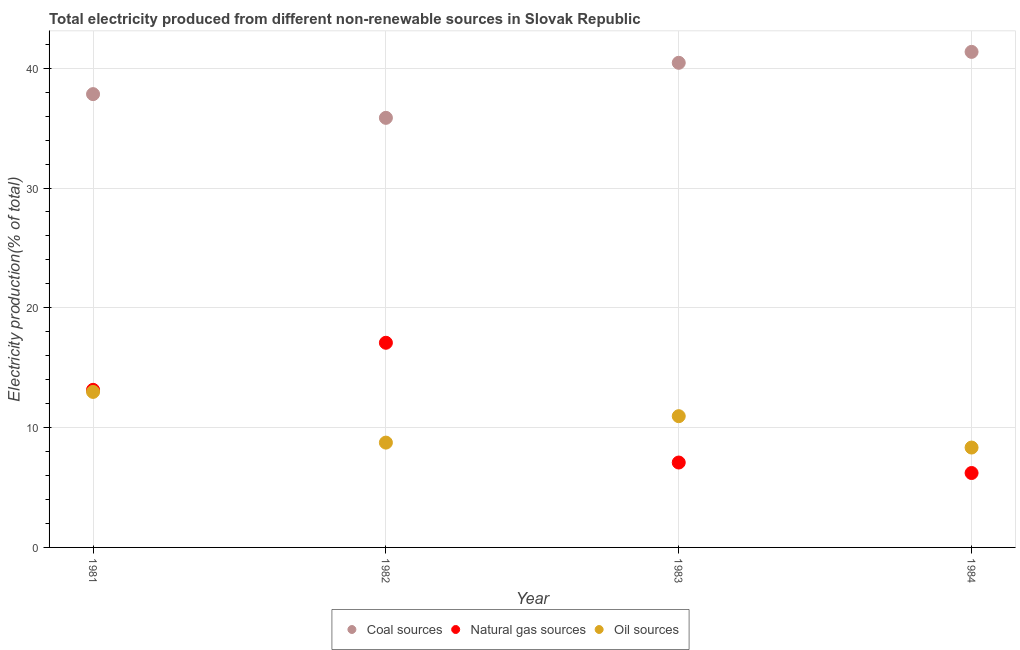What is the percentage of electricity produced by oil sources in 1982?
Make the answer very short. 8.75. Across all years, what is the maximum percentage of electricity produced by coal?
Offer a terse response. 41.36. Across all years, what is the minimum percentage of electricity produced by coal?
Provide a succinct answer. 35.86. What is the total percentage of electricity produced by natural gas in the graph?
Your answer should be compact. 43.54. What is the difference between the percentage of electricity produced by oil sources in 1982 and that in 1984?
Provide a short and direct response. 0.41. What is the difference between the percentage of electricity produced by natural gas in 1982 and the percentage of electricity produced by oil sources in 1984?
Provide a succinct answer. 8.75. What is the average percentage of electricity produced by coal per year?
Offer a terse response. 38.88. In the year 1984, what is the difference between the percentage of electricity produced by natural gas and percentage of electricity produced by coal?
Keep it short and to the point. -35.15. In how many years, is the percentage of electricity produced by oil sources greater than 36 %?
Provide a succinct answer. 0. What is the ratio of the percentage of electricity produced by oil sources in 1983 to that in 1984?
Your response must be concise. 1.31. Is the percentage of electricity produced by oil sources in 1982 less than that in 1984?
Offer a terse response. No. Is the difference between the percentage of electricity produced by oil sources in 1981 and 1982 greater than the difference between the percentage of electricity produced by coal in 1981 and 1982?
Your answer should be compact. Yes. What is the difference between the highest and the second highest percentage of electricity produced by oil sources?
Your response must be concise. 2.03. What is the difference between the highest and the lowest percentage of electricity produced by oil sources?
Provide a succinct answer. 4.64. In how many years, is the percentage of electricity produced by coal greater than the average percentage of electricity produced by coal taken over all years?
Provide a short and direct response. 2. Is the sum of the percentage of electricity produced by coal in 1981 and 1982 greater than the maximum percentage of electricity produced by natural gas across all years?
Provide a short and direct response. Yes. Is it the case that in every year, the sum of the percentage of electricity produced by coal and percentage of electricity produced by natural gas is greater than the percentage of electricity produced by oil sources?
Your answer should be very brief. Yes. How many years are there in the graph?
Keep it short and to the point. 4. What is the difference between two consecutive major ticks on the Y-axis?
Your answer should be very brief. 10. Are the values on the major ticks of Y-axis written in scientific E-notation?
Make the answer very short. No. Does the graph contain any zero values?
Your response must be concise. No. Does the graph contain grids?
Keep it short and to the point. Yes. Where does the legend appear in the graph?
Your answer should be very brief. Bottom center. How many legend labels are there?
Your answer should be very brief. 3. How are the legend labels stacked?
Provide a succinct answer. Horizontal. What is the title of the graph?
Provide a succinct answer. Total electricity produced from different non-renewable sources in Slovak Republic. Does "Labor Tax" appear as one of the legend labels in the graph?
Keep it short and to the point. No. What is the label or title of the Y-axis?
Keep it short and to the point. Electricity production(% of total). What is the Electricity production(% of total) of Coal sources in 1981?
Keep it short and to the point. 37.84. What is the Electricity production(% of total) of Natural gas sources in 1981?
Your answer should be very brief. 13.15. What is the Electricity production(% of total) of Oil sources in 1981?
Provide a short and direct response. 12.98. What is the Electricity production(% of total) in Coal sources in 1982?
Make the answer very short. 35.86. What is the Electricity production(% of total) of Natural gas sources in 1982?
Offer a very short reply. 17.08. What is the Electricity production(% of total) in Oil sources in 1982?
Provide a succinct answer. 8.75. What is the Electricity production(% of total) in Coal sources in 1983?
Keep it short and to the point. 40.45. What is the Electricity production(% of total) in Natural gas sources in 1983?
Provide a succinct answer. 7.09. What is the Electricity production(% of total) of Oil sources in 1983?
Ensure brevity in your answer.  10.96. What is the Electricity production(% of total) in Coal sources in 1984?
Provide a succinct answer. 41.36. What is the Electricity production(% of total) of Natural gas sources in 1984?
Provide a succinct answer. 6.21. What is the Electricity production(% of total) of Oil sources in 1984?
Provide a short and direct response. 8.34. Across all years, what is the maximum Electricity production(% of total) in Coal sources?
Your answer should be compact. 41.36. Across all years, what is the maximum Electricity production(% of total) of Natural gas sources?
Your answer should be compact. 17.08. Across all years, what is the maximum Electricity production(% of total) in Oil sources?
Your response must be concise. 12.98. Across all years, what is the minimum Electricity production(% of total) of Coal sources?
Give a very brief answer. 35.86. Across all years, what is the minimum Electricity production(% of total) in Natural gas sources?
Provide a short and direct response. 6.21. Across all years, what is the minimum Electricity production(% of total) of Oil sources?
Make the answer very short. 8.34. What is the total Electricity production(% of total) in Coal sources in the graph?
Give a very brief answer. 155.51. What is the total Electricity production(% of total) of Natural gas sources in the graph?
Your answer should be very brief. 43.54. What is the total Electricity production(% of total) in Oil sources in the graph?
Offer a terse response. 41.02. What is the difference between the Electricity production(% of total) in Coal sources in 1981 and that in 1982?
Your response must be concise. 1.98. What is the difference between the Electricity production(% of total) in Natural gas sources in 1981 and that in 1982?
Make the answer very short. -3.93. What is the difference between the Electricity production(% of total) of Oil sources in 1981 and that in 1982?
Offer a very short reply. 4.23. What is the difference between the Electricity production(% of total) of Coal sources in 1981 and that in 1983?
Offer a terse response. -2.62. What is the difference between the Electricity production(% of total) of Natural gas sources in 1981 and that in 1983?
Make the answer very short. 6.07. What is the difference between the Electricity production(% of total) in Oil sources in 1981 and that in 1983?
Ensure brevity in your answer.  2.03. What is the difference between the Electricity production(% of total) in Coal sources in 1981 and that in 1984?
Provide a succinct answer. -3.53. What is the difference between the Electricity production(% of total) in Natural gas sources in 1981 and that in 1984?
Keep it short and to the point. 6.94. What is the difference between the Electricity production(% of total) of Oil sources in 1981 and that in 1984?
Keep it short and to the point. 4.64. What is the difference between the Electricity production(% of total) in Coal sources in 1982 and that in 1983?
Make the answer very short. -4.6. What is the difference between the Electricity production(% of total) in Natural gas sources in 1982 and that in 1983?
Provide a succinct answer. 10. What is the difference between the Electricity production(% of total) of Oil sources in 1982 and that in 1983?
Your response must be concise. -2.21. What is the difference between the Electricity production(% of total) in Coal sources in 1982 and that in 1984?
Provide a short and direct response. -5.51. What is the difference between the Electricity production(% of total) in Natural gas sources in 1982 and that in 1984?
Provide a succinct answer. 10.87. What is the difference between the Electricity production(% of total) in Oil sources in 1982 and that in 1984?
Make the answer very short. 0.41. What is the difference between the Electricity production(% of total) of Coal sources in 1983 and that in 1984?
Offer a terse response. -0.91. What is the difference between the Electricity production(% of total) of Natural gas sources in 1983 and that in 1984?
Provide a short and direct response. 0.88. What is the difference between the Electricity production(% of total) in Oil sources in 1983 and that in 1984?
Offer a very short reply. 2.62. What is the difference between the Electricity production(% of total) of Coal sources in 1981 and the Electricity production(% of total) of Natural gas sources in 1982?
Make the answer very short. 20.75. What is the difference between the Electricity production(% of total) in Coal sources in 1981 and the Electricity production(% of total) in Oil sources in 1982?
Make the answer very short. 29.09. What is the difference between the Electricity production(% of total) of Natural gas sources in 1981 and the Electricity production(% of total) of Oil sources in 1982?
Provide a succinct answer. 4.4. What is the difference between the Electricity production(% of total) in Coal sources in 1981 and the Electricity production(% of total) in Natural gas sources in 1983?
Offer a terse response. 30.75. What is the difference between the Electricity production(% of total) of Coal sources in 1981 and the Electricity production(% of total) of Oil sources in 1983?
Provide a succinct answer. 26.88. What is the difference between the Electricity production(% of total) in Natural gas sources in 1981 and the Electricity production(% of total) in Oil sources in 1983?
Provide a short and direct response. 2.2. What is the difference between the Electricity production(% of total) of Coal sources in 1981 and the Electricity production(% of total) of Natural gas sources in 1984?
Provide a short and direct response. 31.63. What is the difference between the Electricity production(% of total) in Coal sources in 1981 and the Electricity production(% of total) in Oil sources in 1984?
Provide a succinct answer. 29.5. What is the difference between the Electricity production(% of total) of Natural gas sources in 1981 and the Electricity production(% of total) of Oil sources in 1984?
Your answer should be compact. 4.82. What is the difference between the Electricity production(% of total) in Coal sources in 1982 and the Electricity production(% of total) in Natural gas sources in 1983?
Provide a short and direct response. 28.77. What is the difference between the Electricity production(% of total) of Coal sources in 1982 and the Electricity production(% of total) of Oil sources in 1983?
Give a very brief answer. 24.9. What is the difference between the Electricity production(% of total) of Natural gas sources in 1982 and the Electricity production(% of total) of Oil sources in 1983?
Ensure brevity in your answer.  6.13. What is the difference between the Electricity production(% of total) in Coal sources in 1982 and the Electricity production(% of total) in Natural gas sources in 1984?
Offer a very short reply. 29.65. What is the difference between the Electricity production(% of total) of Coal sources in 1982 and the Electricity production(% of total) of Oil sources in 1984?
Provide a short and direct response. 27.52. What is the difference between the Electricity production(% of total) in Natural gas sources in 1982 and the Electricity production(% of total) in Oil sources in 1984?
Your answer should be very brief. 8.75. What is the difference between the Electricity production(% of total) in Coal sources in 1983 and the Electricity production(% of total) in Natural gas sources in 1984?
Ensure brevity in your answer.  34.24. What is the difference between the Electricity production(% of total) of Coal sources in 1983 and the Electricity production(% of total) of Oil sources in 1984?
Give a very brief answer. 32.12. What is the difference between the Electricity production(% of total) of Natural gas sources in 1983 and the Electricity production(% of total) of Oil sources in 1984?
Your answer should be very brief. -1.25. What is the average Electricity production(% of total) in Coal sources per year?
Offer a terse response. 38.88. What is the average Electricity production(% of total) of Natural gas sources per year?
Provide a short and direct response. 10.88. What is the average Electricity production(% of total) in Oil sources per year?
Make the answer very short. 10.26. In the year 1981, what is the difference between the Electricity production(% of total) in Coal sources and Electricity production(% of total) in Natural gas sources?
Offer a very short reply. 24.68. In the year 1981, what is the difference between the Electricity production(% of total) in Coal sources and Electricity production(% of total) in Oil sources?
Give a very brief answer. 24.86. In the year 1981, what is the difference between the Electricity production(% of total) in Natural gas sources and Electricity production(% of total) in Oil sources?
Provide a short and direct response. 0.17. In the year 1982, what is the difference between the Electricity production(% of total) of Coal sources and Electricity production(% of total) of Natural gas sources?
Offer a very short reply. 18.77. In the year 1982, what is the difference between the Electricity production(% of total) of Coal sources and Electricity production(% of total) of Oil sources?
Make the answer very short. 27.11. In the year 1982, what is the difference between the Electricity production(% of total) in Natural gas sources and Electricity production(% of total) in Oil sources?
Your answer should be compact. 8.33. In the year 1983, what is the difference between the Electricity production(% of total) in Coal sources and Electricity production(% of total) in Natural gas sources?
Make the answer very short. 33.37. In the year 1983, what is the difference between the Electricity production(% of total) of Coal sources and Electricity production(% of total) of Oil sources?
Keep it short and to the point. 29.5. In the year 1983, what is the difference between the Electricity production(% of total) in Natural gas sources and Electricity production(% of total) in Oil sources?
Provide a succinct answer. -3.87. In the year 1984, what is the difference between the Electricity production(% of total) of Coal sources and Electricity production(% of total) of Natural gas sources?
Offer a very short reply. 35.15. In the year 1984, what is the difference between the Electricity production(% of total) in Coal sources and Electricity production(% of total) in Oil sources?
Ensure brevity in your answer.  33.03. In the year 1984, what is the difference between the Electricity production(% of total) in Natural gas sources and Electricity production(% of total) in Oil sources?
Your answer should be very brief. -2.13. What is the ratio of the Electricity production(% of total) in Coal sources in 1981 to that in 1982?
Give a very brief answer. 1.06. What is the ratio of the Electricity production(% of total) of Natural gas sources in 1981 to that in 1982?
Your response must be concise. 0.77. What is the ratio of the Electricity production(% of total) of Oil sources in 1981 to that in 1982?
Keep it short and to the point. 1.48. What is the ratio of the Electricity production(% of total) in Coal sources in 1981 to that in 1983?
Your answer should be compact. 0.94. What is the ratio of the Electricity production(% of total) of Natural gas sources in 1981 to that in 1983?
Give a very brief answer. 1.86. What is the ratio of the Electricity production(% of total) in Oil sources in 1981 to that in 1983?
Provide a short and direct response. 1.18. What is the ratio of the Electricity production(% of total) of Coal sources in 1981 to that in 1984?
Offer a terse response. 0.91. What is the ratio of the Electricity production(% of total) of Natural gas sources in 1981 to that in 1984?
Provide a succinct answer. 2.12. What is the ratio of the Electricity production(% of total) in Oil sources in 1981 to that in 1984?
Your answer should be compact. 1.56. What is the ratio of the Electricity production(% of total) in Coal sources in 1982 to that in 1983?
Your answer should be compact. 0.89. What is the ratio of the Electricity production(% of total) of Natural gas sources in 1982 to that in 1983?
Provide a short and direct response. 2.41. What is the ratio of the Electricity production(% of total) in Oil sources in 1982 to that in 1983?
Offer a very short reply. 0.8. What is the ratio of the Electricity production(% of total) in Coal sources in 1982 to that in 1984?
Your response must be concise. 0.87. What is the ratio of the Electricity production(% of total) of Natural gas sources in 1982 to that in 1984?
Keep it short and to the point. 2.75. What is the ratio of the Electricity production(% of total) in Oil sources in 1982 to that in 1984?
Your answer should be very brief. 1.05. What is the ratio of the Electricity production(% of total) in Natural gas sources in 1983 to that in 1984?
Your response must be concise. 1.14. What is the ratio of the Electricity production(% of total) in Oil sources in 1983 to that in 1984?
Keep it short and to the point. 1.31. What is the difference between the highest and the second highest Electricity production(% of total) in Coal sources?
Offer a very short reply. 0.91. What is the difference between the highest and the second highest Electricity production(% of total) of Natural gas sources?
Your answer should be very brief. 3.93. What is the difference between the highest and the second highest Electricity production(% of total) in Oil sources?
Your answer should be very brief. 2.03. What is the difference between the highest and the lowest Electricity production(% of total) in Coal sources?
Make the answer very short. 5.51. What is the difference between the highest and the lowest Electricity production(% of total) of Natural gas sources?
Your answer should be compact. 10.87. What is the difference between the highest and the lowest Electricity production(% of total) in Oil sources?
Your answer should be very brief. 4.64. 